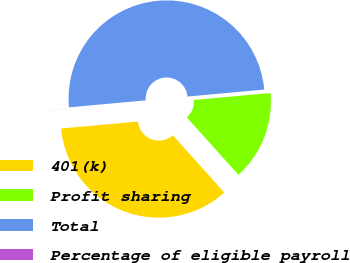Convert chart. <chart><loc_0><loc_0><loc_500><loc_500><pie_chart><fcel>401(k)<fcel>Profit sharing<fcel>Total<fcel>Percentage of eligible payroll<nl><fcel>35.19%<fcel>14.8%<fcel>49.99%<fcel>0.01%<nl></chart> 